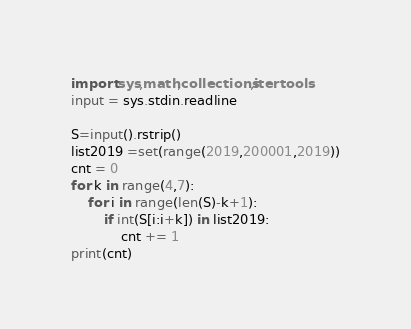Convert code to text. <code><loc_0><loc_0><loc_500><loc_500><_Python_>import sys,math,collections,itertools
input = sys.stdin.readline

S=input().rstrip()
list2019 =set(range(2019,200001,2019))
cnt = 0
for k in range(4,7):
    for i in range(len(S)-k+1):
        if int(S[i:i+k]) in list2019:
            cnt += 1  
print(cnt)
</code> 